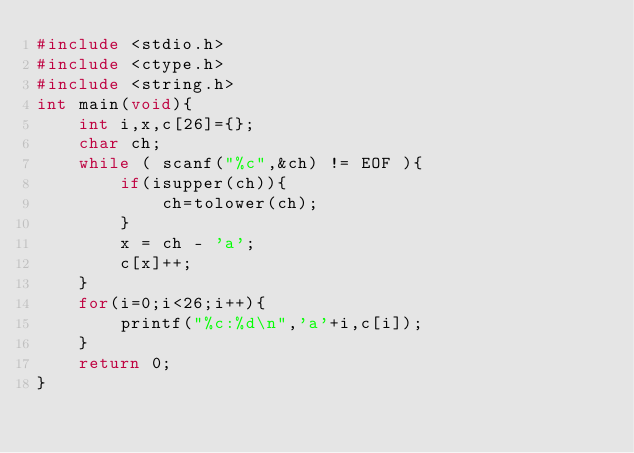<code> <loc_0><loc_0><loc_500><loc_500><_C_>#include <stdio.h>
#include <ctype.h>
#include <string.h>
int main(void){
    int i,x,c[26]={};
    char ch;
    while ( scanf("%c",&ch) != EOF ){
        if(isupper(ch)){
            ch=tolower(ch);
        }
        x = ch - 'a';
        c[x]++;
    }
    for(i=0;i<26;i++){
        printf("%c:%d\n",'a'+i,c[i]);
    }
    return 0;
}

</code> 